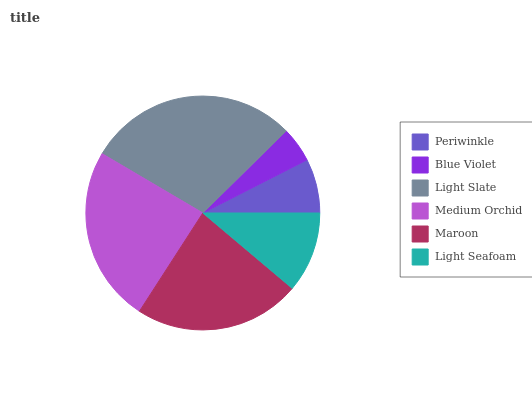Is Blue Violet the minimum?
Answer yes or no. Yes. Is Light Slate the maximum?
Answer yes or no. Yes. Is Light Slate the minimum?
Answer yes or no. No. Is Blue Violet the maximum?
Answer yes or no. No. Is Light Slate greater than Blue Violet?
Answer yes or no. Yes. Is Blue Violet less than Light Slate?
Answer yes or no. Yes. Is Blue Violet greater than Light Slate?
Answer yes or no. No. Is Light Slate less than Blue Violet?
Answer yes or no. No. Is Maroon the high median?
Answer yes or no. Yes. Is Light Seafoam the low median?
Answer yes or no. Yes. Is Medium Orchid the high median?
Answer yes or no. No. Is Periwinkle the low median?
Answer yes or no. No. 